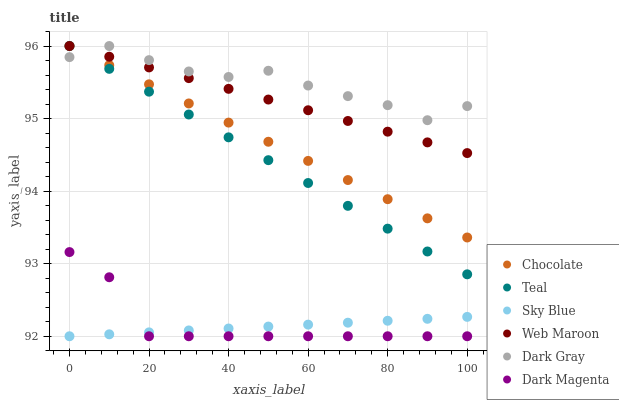Does Sky Blue have the minimum area under the curve?
Answer yes or no. Yes. Does Dark Gray have the maximum area under the curve?
Answer yes or no. Yes. Does Web Maroon have the minimum area under the curve?
Answer yes or no. No. Does Web Maroon have the maximum area under the curve?
Answer yes or no. No. Is Teal the smoothest?
Answer yes or no. Yes. Is Dark Gray the roughest?
Answer yes or no. Yes. Is Web Maroon the smoothest?
Answer yes or no. No. Is Web Maroon the roughest?
Answer yes or no. No. Does Dark Magenta have the lowest value?
Answer yes or no. Yes. Does Web Maroon have the lowest value?
Answer yes or no. No. Does Teal have the highest value?
Answer yes or no. Yes. Does Sky Blue have the highest value?
Answer yes or no. No. Is Sky Blue less than Web Maroon?
Answer yes or no. Yes. Is Chocolate greater than Sky Blue?
Answer yes or no. Yes. Does Teal intersect Dark Gray?
Answer yes or no. Yes. Is Teal less than Dark Gray?
Answer yes or no. No. Is Teal greater than Dark Gray?
Answer yes or no. No. Does Sky Blue intersect Web Maroon?
Answer yes or no. No. 